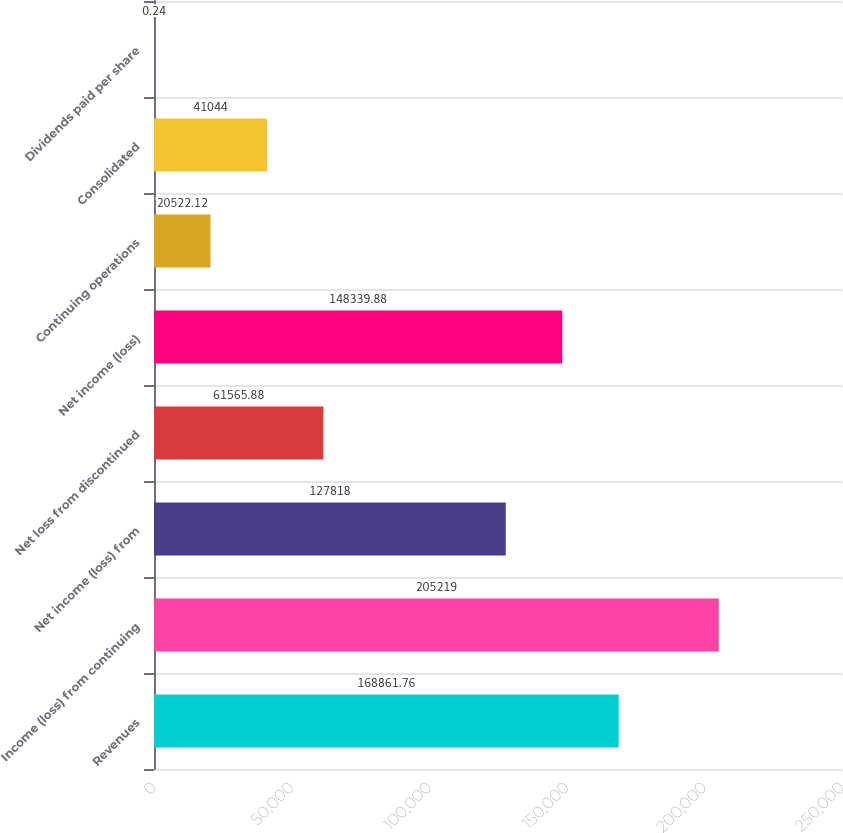Convert chart to OTSL. <chart><loc_0><loc_0><loc_500><loc_500><bar_chart><fcel>Revenues<fcel>Income (loss) from continuing<fcel>Net income (loss) from<fcel>Net loss from discontinued<fcel>Net income (loss)<fcel>Continuing operations<fcel>Consolidated<fcel>Dividends paid per share<nl><fcel>168862<fcel>205219<fcel>127818<fcel>61565.9<fcel>148340<fcel>20522.1<fcel>41044<fcel>0.24<nl></chart> 